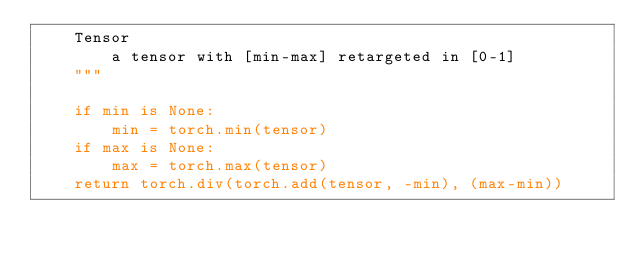Convert code to text. <code><loc_0><loc_0><loc_500><loc_500><_Python_>    Tensor
        a tensor with [min-max] retargeted in [0-1]
    """

    if min is None:
        min = torch.min(tensor)
    if max is None:
        max = torch.max(tensor)
    return torch.div(torch.add(tensor, -min), (max-min))
</code> 